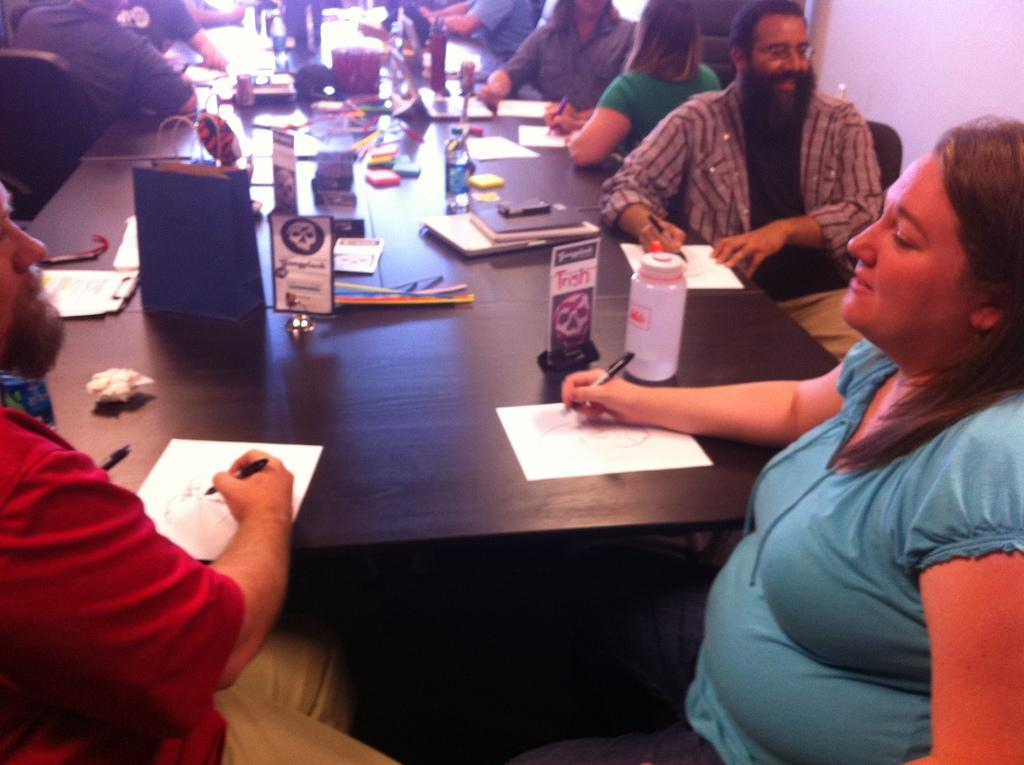How many people are in the room in the image? There are many persons in the room in the image. What are the persons in the room doing? The persons are sitting in the room. What is in front of the persons in the room? There is a table in front of the persons in the room. What are the persons holding in their hands? The persons are holding pens in their hands. What is on the table in the room? There are papers, bottles, books, and other items on the table in the room. What type of alarm is going off in the room in the image? There is no alarm going off in the room in the image. Are there any spiders crawling on the persons or items in the room in the image? There is no mention of spiders in the image, so we cannot determine if they are present or not. 